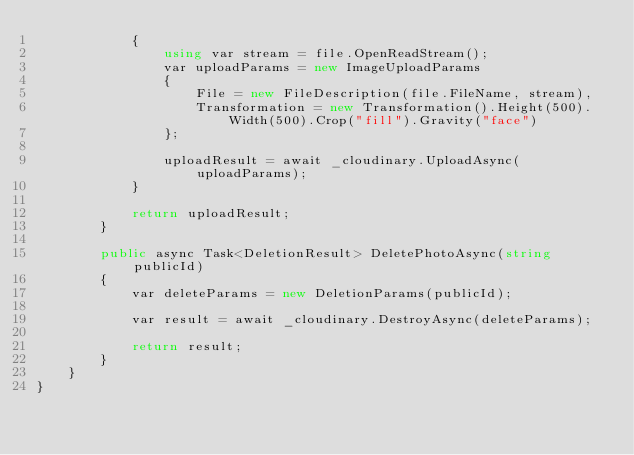Convert code to text. <code><loc_0><loc_0><loc_500><loc_500><_C#_>            {
                using var stream = file.OpenReadStream();
                var uploadParams = new ImageUploadParams
                {
                    File = new FileDescription(file.FileName, stream),
                    Transformation = new Transformation().Height(500).Width(500).Crop("fill").Gravity("face")
                };

                uploadResult = await _cloudinary.UploadAsync(uploadParams);
            }

            return uploadResult;
        }

        public async Task<DeletionResult> DeletePhotoAsync(string publicId)
        {
            var deleteParams = new DeletionParams(publicId);

            var result = await _cloudinary.DestroyAsync(deleteParams);

            return result;
        }
    }
}</code> 